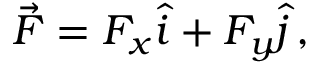<formula> <loc_0><loc_0><loc_500><loc_500>\begin{array} { r } { \vec { F } = F _ { x } \hat { i } + F _ { y } \hat { j } \, , } \end{array}</formula> 